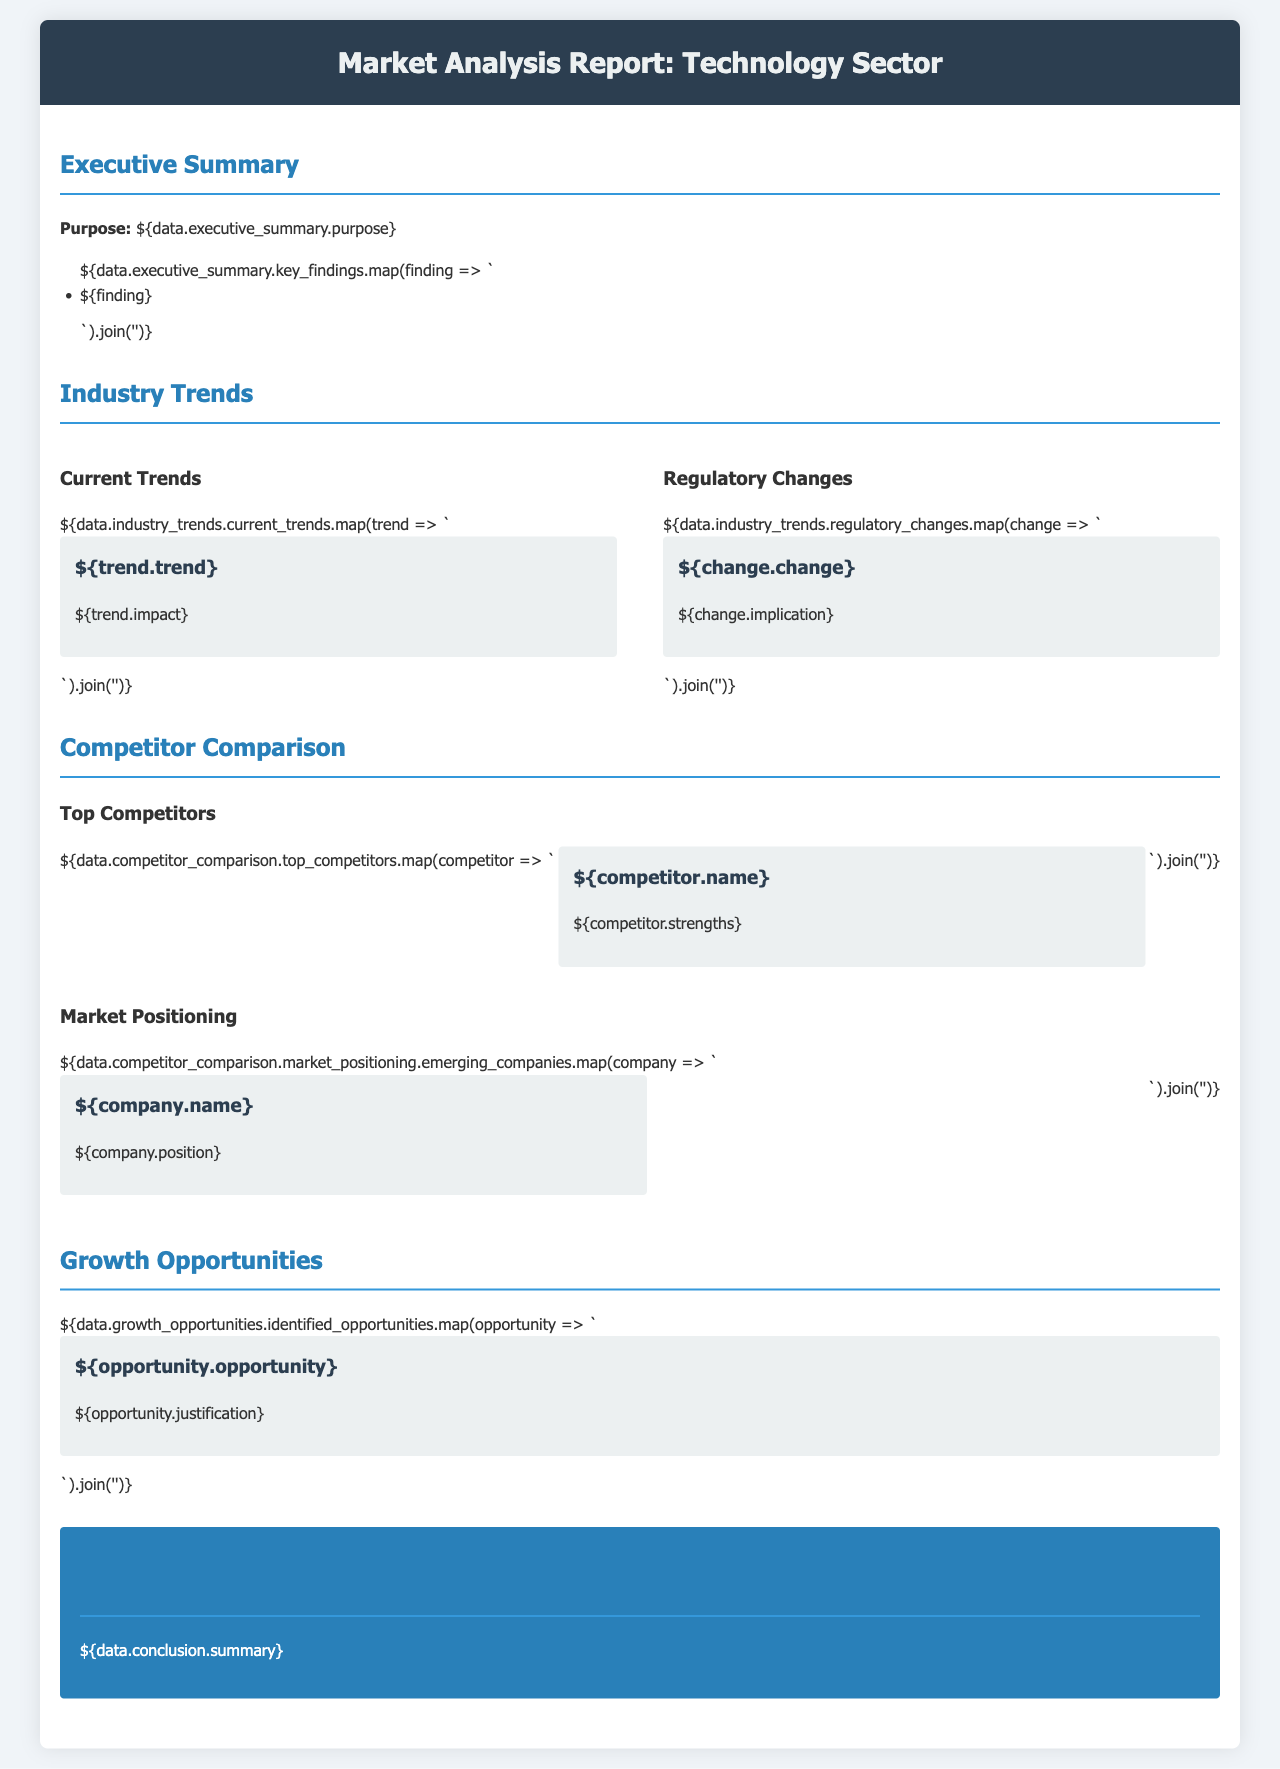what is the purpose of the report? The purpose is stated in the executive summary section of the document.
Answer: To analyze the technology sector what are the key findings of the report? The key findings are listed in the executive summary and offer insights into the analysis.
Answer: Key findings how many current trends are identified in the industry trends? The number of current trends is based on the listed elements in the current trends section.
Answer: X trends who are the top competitors mentioned in the competitor comparison? The top competitors are named in the competitor comparison section of the document.
Answer: Competitor names what is the summary of the conclusion? The conclusion provides a summary of insights derived from the analysis, which is stated in that section.
Answer: Conclusion summary what growth opportunities have been identified? The identified opportunities are listed in the growth opportunities section and justify the potential for development.
Answer: Opportunity names which regulatory changes are noted in the industry trends? The regulatory changes are described in the relevant section, highlighting important implications.
Answer: Regulatory changes how is the market positioning of emerging companies described? The market positioning is outlined in the competitor comparison section, summarizing the positioning of the emerging companies.
Answer: Market positioning descriptions what are the implications of the described regulatory changes? The implications are summarized in the regulatory changes section and indicate potential impacts on the industry.
Answer: Implications 